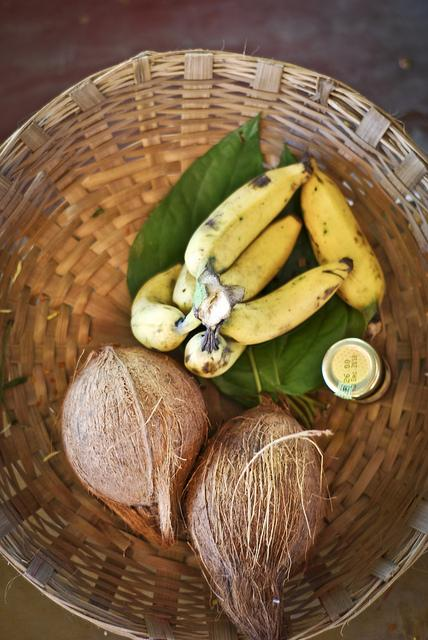What is the best climate for these fruits to grow in? Please explain your reasoning. tropical. The visible fruits are bananas and coconuts. the trees that these plants grow on are known to be found in tropical climates. 